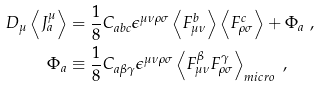<formula> <loc_0><loc_0><loc_500><loc_500>D _ { \mu } \left < J _ { a } ^ { \mu } \right > & = \frac { 1 } { 8 } C _ { a b c } \epsilon ^ { \mu \nu \rho \sigma } \left < F ^ { b } _ { \mu \nu } \right > \left < F ^ { c } _ { \rho \sigma } \right > + \Phi _ { a } \ , \\ \Phi _ { a } & \equiv \frac { 1 } { 8 } C _ { a \beta \gamma } \epsilon ^ { \mu \nu \rho \sigma } \left < F ^ { \beta } _ { \mu \nu } F ^ { \gamma } _ { \rho \sigma } \right > _ { m i c r o } \ ,</formula> 